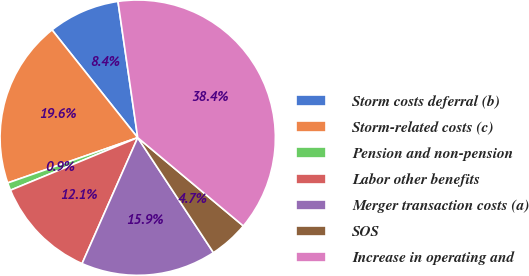<chart> <loc_0><loc_0><loc_500><loc_500><pie_chart><fcel>Storm costs deferral (b)<fcel>Storm-related costs (c)<fcel>Pension and non-pension<fcel>Labor other benefits<fcel>Merger transaction costs (a)<fcel>SOS<fcel>Increase in operating and<nl><fcel>8.4%<fcel>19.64%<fcel>0.9%<fcel>12.14%<fcel>15.89%<fcel>4.65%<fcel>38.37%<nl></chart> 